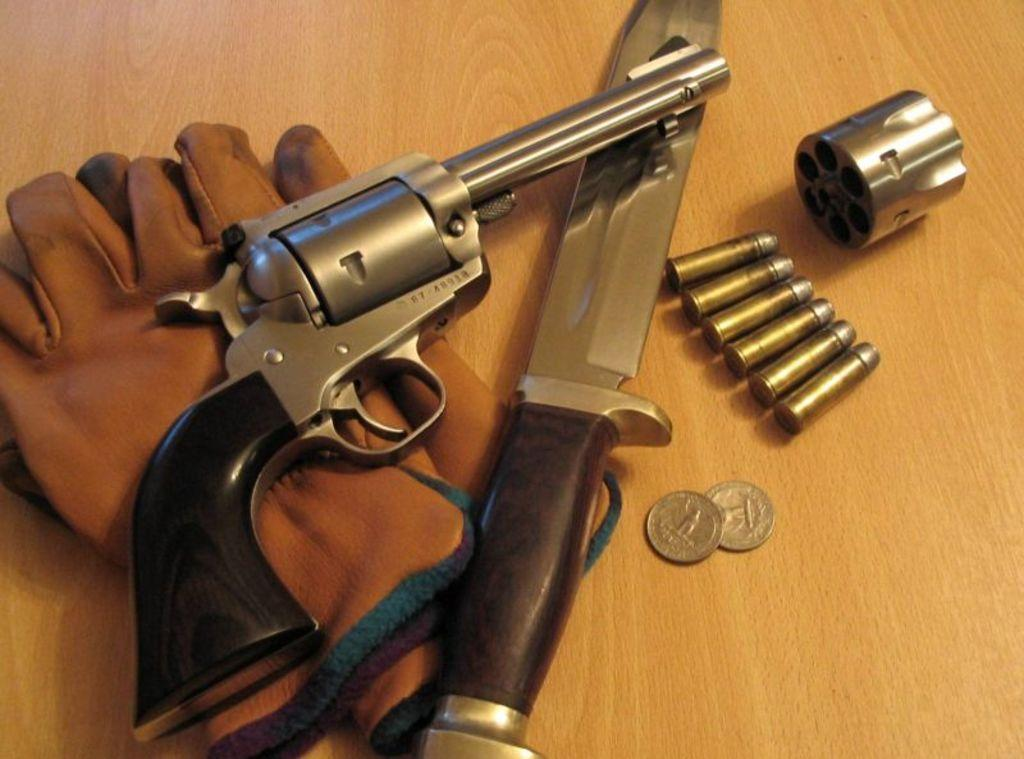What type of weapon is present in the image? There is a gun in the image. What other sharp object can be seen in the image? There is a knife in the image. What small, round objects are in the image? There are coins in the image. What ammunition is present in the image? There are bullets in the image. What type of protective gear is in the image? There are gloves in the image. What is on the table in the image? There is an object on the table in the image. How far is the coast from the car in the image? There is no coast or car present in the image. What is the distance between the gloves and the coins in the image? The gloves and coins are not positioned in a way that allows for a measurement of distance between them in the image. 